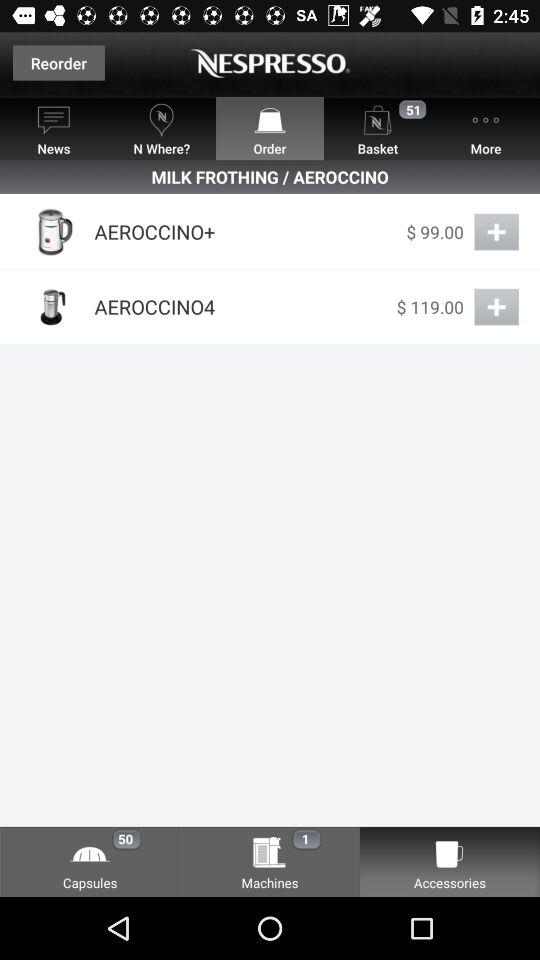What is the number of machines? The number of machines is 1. 